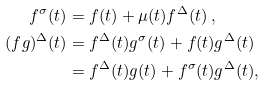<formula> <loc_0><loc_0><loc_500><loc_500>f ^ { \sigma } ( t ) & = f ( t ) + \mu ( t ) f ^ { \Delta } ( t ) \, , \\ ( f g ) ^ { \Delta } ( t ) & = f ^ { \Delta } ( t ) g ^ { \sigma } ( t ) + f ( t ) g ^ { \Delta } ( t ) \\ & = f ^ { \Delta } ( t ) g ( t ) + f ^ { \sigma } ( t ) g ^ { \Delta } ( t ) ,</formula> 